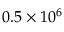Convert formula to latex. <formula><loc_0><loc_0><loc_500><loc_500>0 . 5 \times 1 0 ^ { 6 }</formula> 